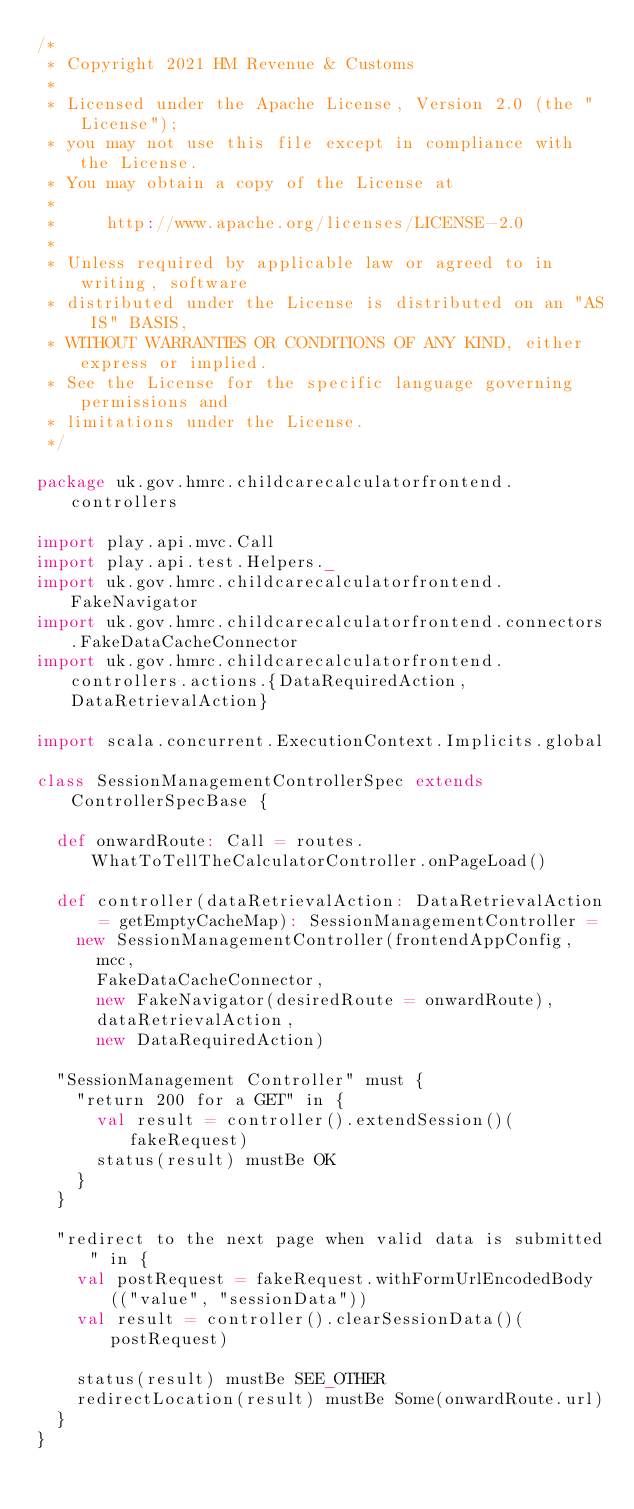Convert code to text. <code><loc_0><loc_0><loc_500><loc_500><_Scala_>/*
 * Copyright 2021 HM Revenue & Customs
 *
 * Licensed under the Apache License, Version 2.0 (the "License");
 * you may not use this file except in compliance with the License.
 * You may obtain a copy of the License at
 *
 *     http://www.apache.org/licenses/LICENSE-2.0
 *
 * Unless required by applicable law or agreed to in writing, software
 * distributed under the License is distributed on an "AS IS" BASIS,
 * WITHOUT WARRANTIES OR CONDITIONS OF ANY KIND, either express or implied.
 * See the License for the specific language governing permissions and
 * limitations under the License.
 */

package uk.gov.hmrc.childcarecalculatorfrontend.controllers

import play.api.mvc.Call
import play.api.test.Helpers._
import uk.gov.hmrc.childcarecalculatorfrontend.FakeNavigator
import uk.gov.hmrc.childcarecalculatorfrontend.connectors.FakeDataCacheConnector
import uk.gov.hmrc.childcarecalculatorfrontend.controllers.actions.{DataRequiredAction, DataRetrievalAction}

import scala.concurrent.ExecutionContext.Implicits.global

class SessionManagementControllerSpec extends ControllerSpecBase {

  def onwardRoute: Call = routes.WhatToTellTheCalculatorController.onPageLoad()

  def controller(dataRetrievalAction: DataRetrievalAction = getEmptyCacheMap): SessionManagementController =
    new SessionManagementController(frontendAppConfig,
      mcc,
      FakeDataCacheConnector,
      new FakeNavigator(desiredRoute = onwardRoute),
      dataRetrievalAction,
      new DataRequiredAction)

  "SessionManagement Controller" must {
    "return 200 for a GET" in {
      val result = controller().extendSession()(fakeRequest)
      status(result) mustBe OK
    }
  }

  "redirect to the next page when valid data is submitted" in {
    val postRequest = fakeRequest.withFormUrlEncodedBody(("value", "sessionData"))
    val result = controller().clearSessionData()(postRequest)

    status(result) mustBe SEE_OTHER
    redirectLocation(result) mustBe Some(onwardRoute.url)
  }
}
</code> 